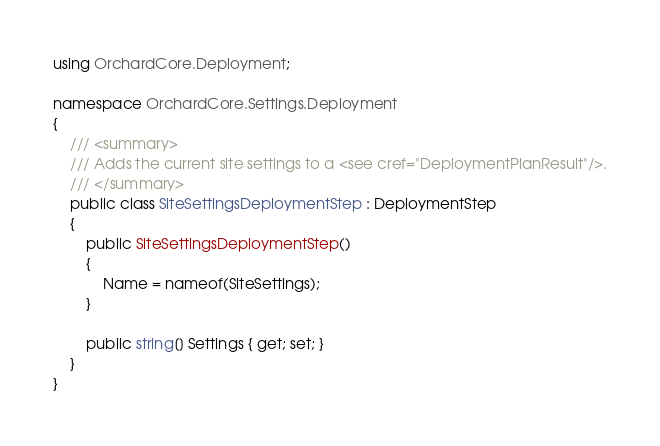<code> <loc_0><loc_0><loc_500><loc_500><_C#_>using OrchardCore.Deployment;

namespace OrchardCore.Settings.Deployment
{
    /// <summary>
    /// Adds the current site settings to a <see cref="DeploymentPlanResult"/>.
    /// </summary>
    public class SiteSettingsDeploymentStep : DeploymentStep
    {
        public SiteSettingsDeploymentStep()
        {
            Name = nameof(SiteSettings);
        }

        public string[] Settings { get; set; }
    }
}
</code> 